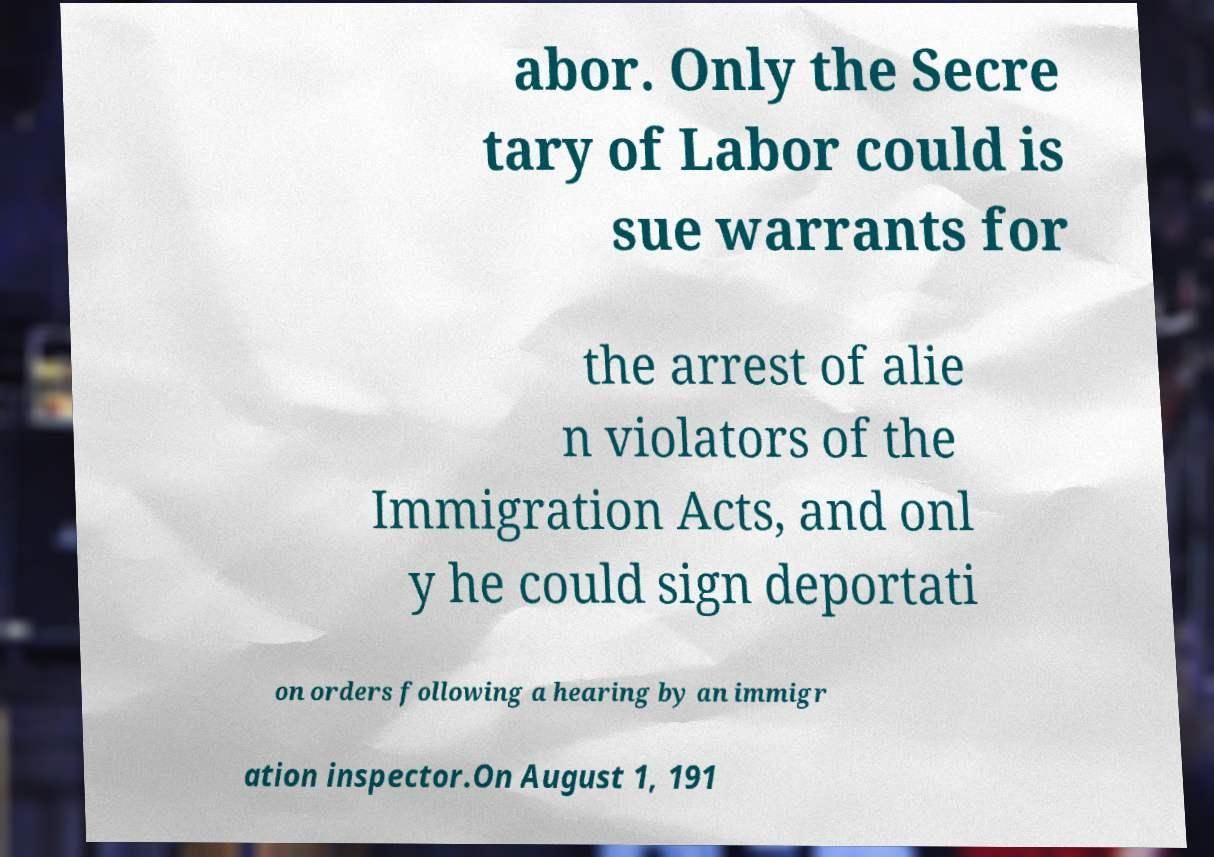For documentation purposes, I need the text within this image transcribed. Could you provide that? abor. Only the Secre tary of Labor could is sue warrants for the arrest of alie n violators of the Immigration Acts, and onl y he could sign deportati on orders following a hearing by an immigr ation inspector.On August 1, 191 